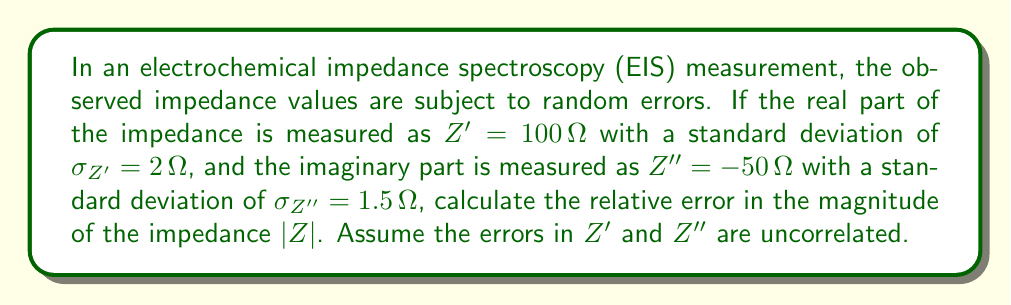Could you help me with this problem? To solve this problem, we'll follow these steps:

1) First, recall that the magnitude of the impedance is given by:

   $$|Z| = \sqrt{(Z')^2 + (Z'')^2}$$

2) We need to use error propagation theory to determine the uncertainty in $|Z|$. For uncorrelated variables, the general formula for error propagation is:

   $$\sigma_f^2 = \sum_i \left(\frac{\partial f}{\partial x_i}\right)^2 \sigma_{x_i}^2$$

   where $f$ is a function of variables $x_i$, and $\sigma_f$ is the standard deviation of $f$.

3) In our case, $f = |Z| = \sqrt{(Z')^2 + (Z'')^2}$. We need to calculate the partial derivatives:

   $$\frac{\partial |Z|}{\partial Z'} = \frac{Z'}{\sqrt{(Z')^2 + (Z'')^2}} = \frac{Z'}{|Z|}$$

   $$\frac{\partial |Z|}{\partial Z''} = \frac{Z''}{\sqrt{(Z')^2 + (Z'')^2}} = \frac{Z''}{|Z|}$$

4) Applying the error propagation formula:

   $$\sigma_{|Z|}^2 = \left(\frac{Z'}{|Z|}\right)^2 \sigma_{Z'}^2 + \left(\frac{Z''}{|Z|}\right)^2 \sigma_{Z''}^2$$

5) Calculate $|Z|$:

   $$|Z| = \sqrt{(100)^2 + (-50)^2} = \sqrt{12500} = 111.80 \Omega$$

6) Now we can substitute all values into the error propagation formula:

   $$\sigma_{|Z|}^2 = \left(\frac{100}{111.80}\right)^2 (2)^2 + \left(\frac{-50}{111.80}\right)^2 (1.5)^2$$

   $$\sigma_{|Z|}^2 = (0.8944)^2 (4) + (-0.4472)^2 (2.25) = 3.2 + 0.45 = 3.65$$

   $$\sigma_{|Z|} = \sqrt{3.65} = 1.91 \Omega$$

7) The relative error is defined as the ratio of the absolute error to the measured value:

   Relative error = $\frac{\sigma_{|Z|}}{|Z|} = \frac{1.91}{111.80} = 0.0171$ or 1.71%
Answer: The relative error in the magnitude of the impedance $|Z|$ is 1.71%. 